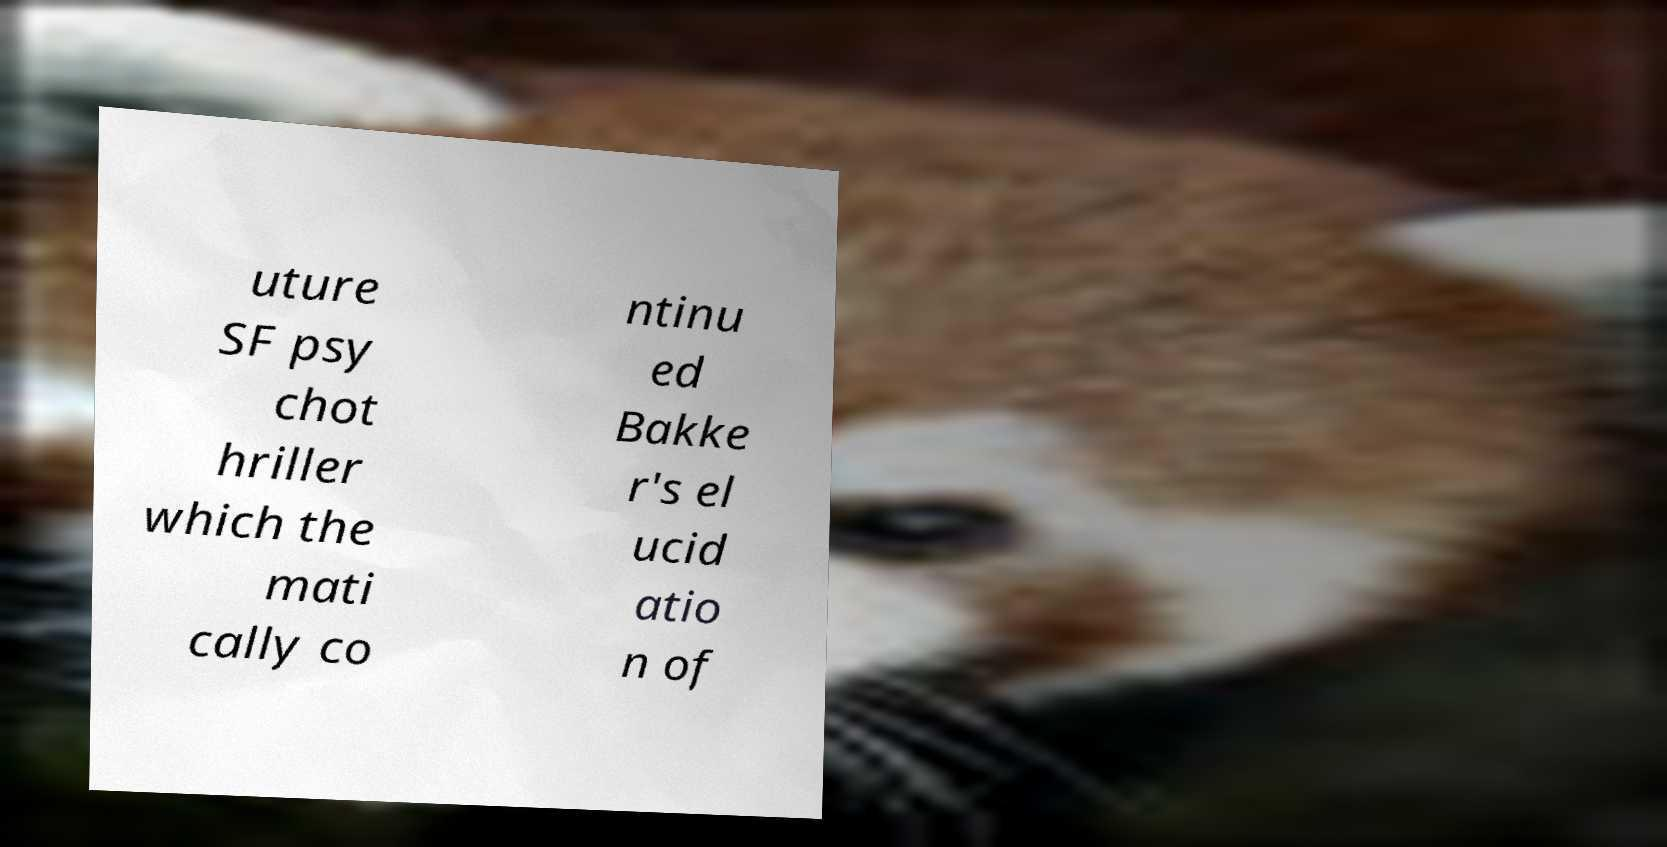Can you accurately transcribe the text from the provided image for me? uture SF psy chot hriller which the mati cally co ntinu ed Bakke r's el ucid atio n of 